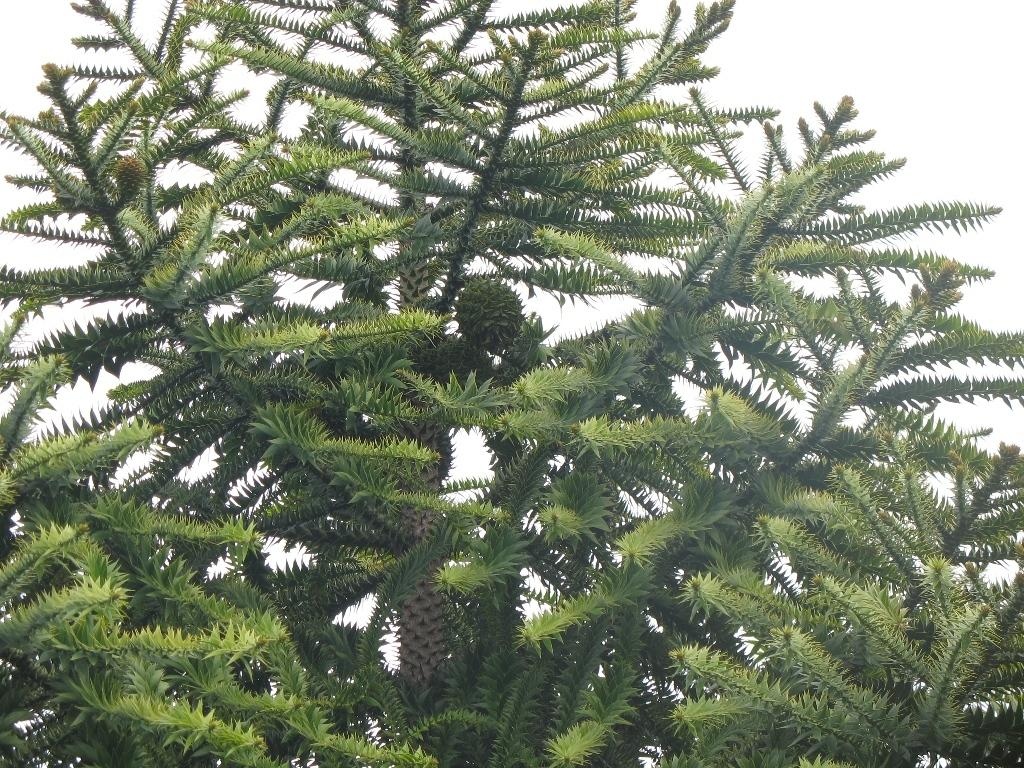What type of vegetation can be seen in the image? There are trees in the image. What color is the background of the image? The background of the image is white. What type of flower is blooming in the image? There are no flowers present in the image; it only features trees. Can you hear any thunder in the image? There is no sound or audio in the image, so it is not possible to determine if there is thunder. 